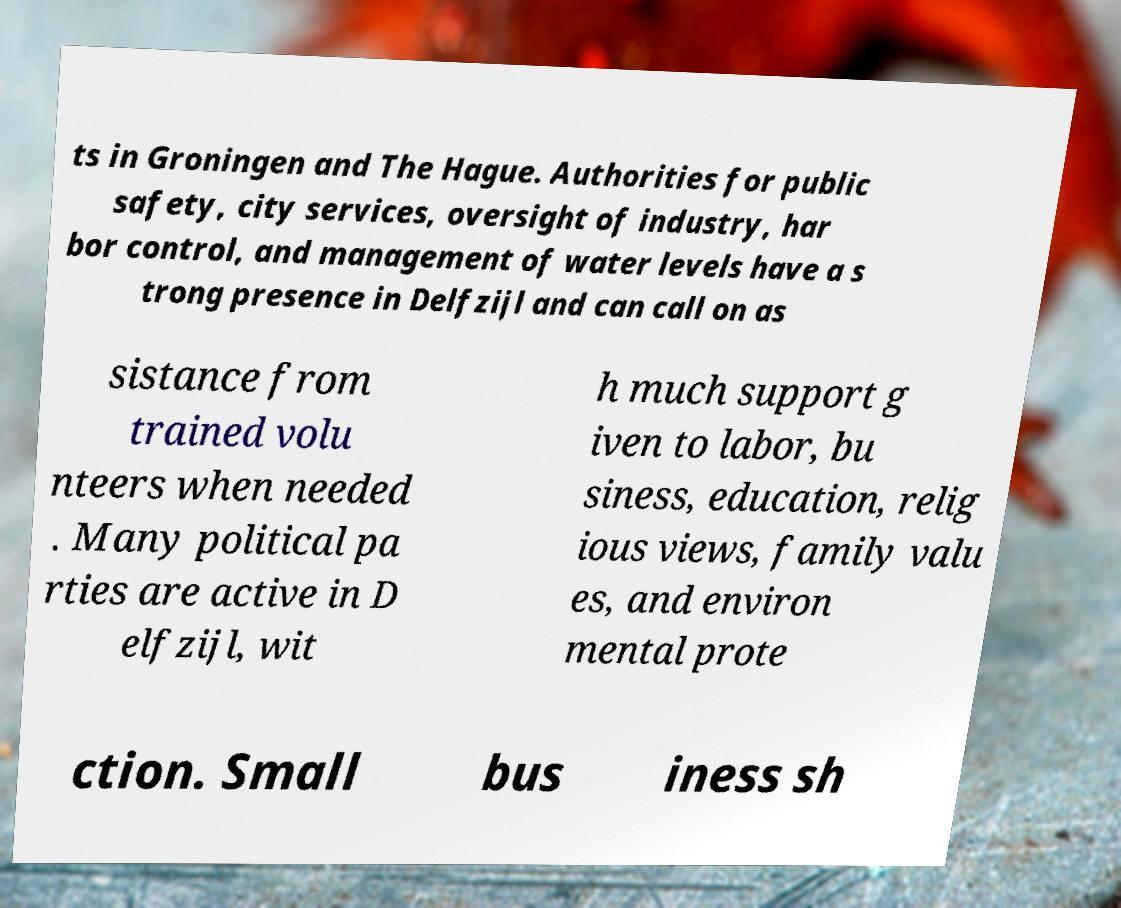What messages or text are displayed in this image? I need them in a readable, typed format. ts in Groningen and The Hague. Authorities for public safety, city services, oversight of industry, har bor control, and management of water levels have a s trong presence in Delfzijl and can call on as sistance from trained volu nteers when needed . Many political pa rties are active in D elfzijl, wit h much support g iven to labor, bu siness, education, relig ious views, family valu es, and environ mental prote ction. Small bus iness sh 